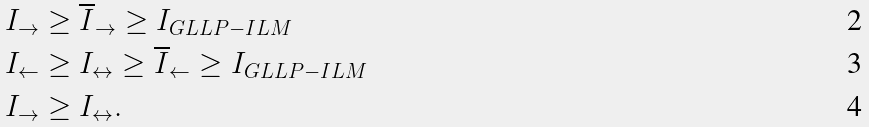Convert formula to latex. <formula><loc_0><loc_0><loc_500><loc_500>I _ { \to } & \geq \overline { I } _ { \to } \geq I _ { G L L P - I L M } \\ I _ { \leftarrow } & \geq I _ { \leftrightarrow } \geq \overline { I } _ { \leftarrow } \geq I _ { G L L P - I L M } \\ I _ { \to } & \geq I _ { \leftrightarrow } .</formula> 